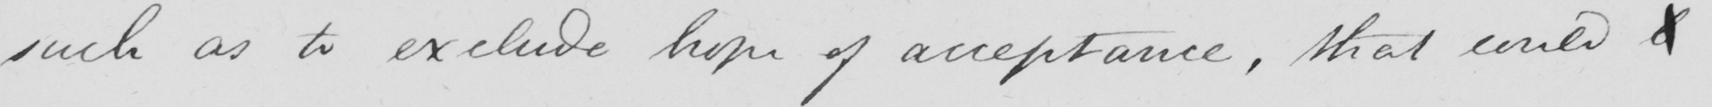Please provide the text content of this handwritten line. such as to exclude hope of acceptance , that could b 